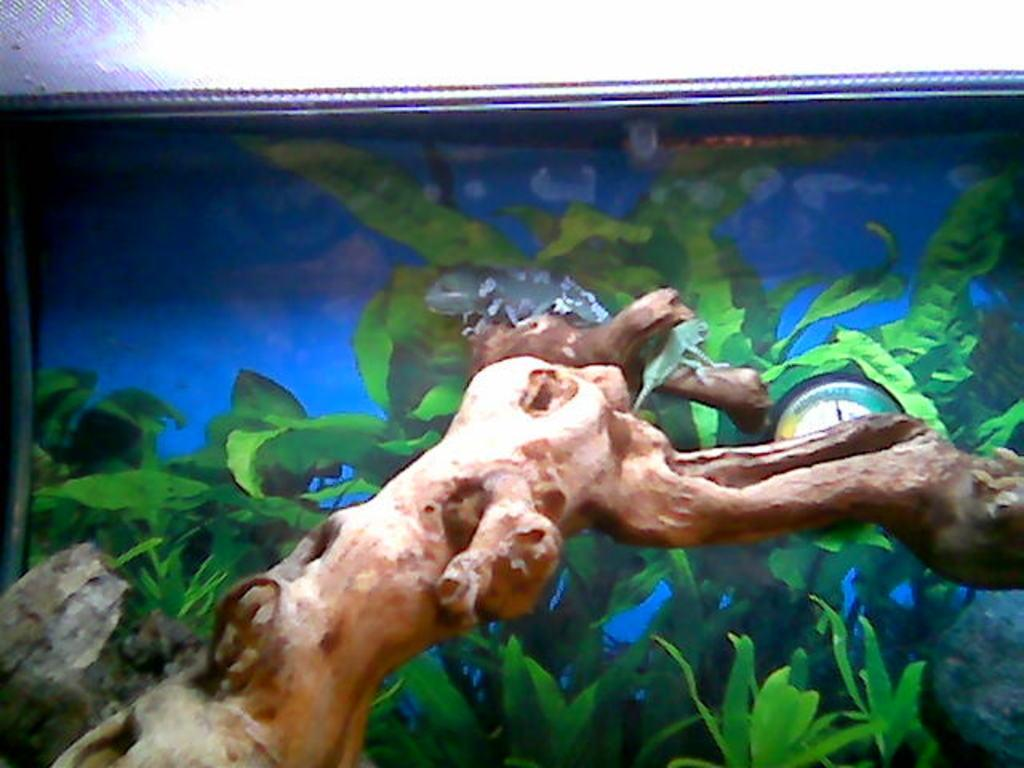What type of living organisms can be seen in the image? Plants and reptiles are visible in the image. What object can be seen in the image that is typically found on trees? There is a branch in the image. What type of geological formation is present in the image? There is a rock in the image. What type of structure is present in the image that might hold or display the image? There is a frame in the image. What type of instrument is present in the image that measures or indicates something? There is a gauge in the image. What color is the background of the image? The background of the image is blue. Can you tell me how many fans are visible in the image? There are no fans present in the image. What type of animal can be seen walking in the image? There are no animals walking in the image; the reptiles are stationary. Where is the zoo located in the image? There is no zoo present in the image. 